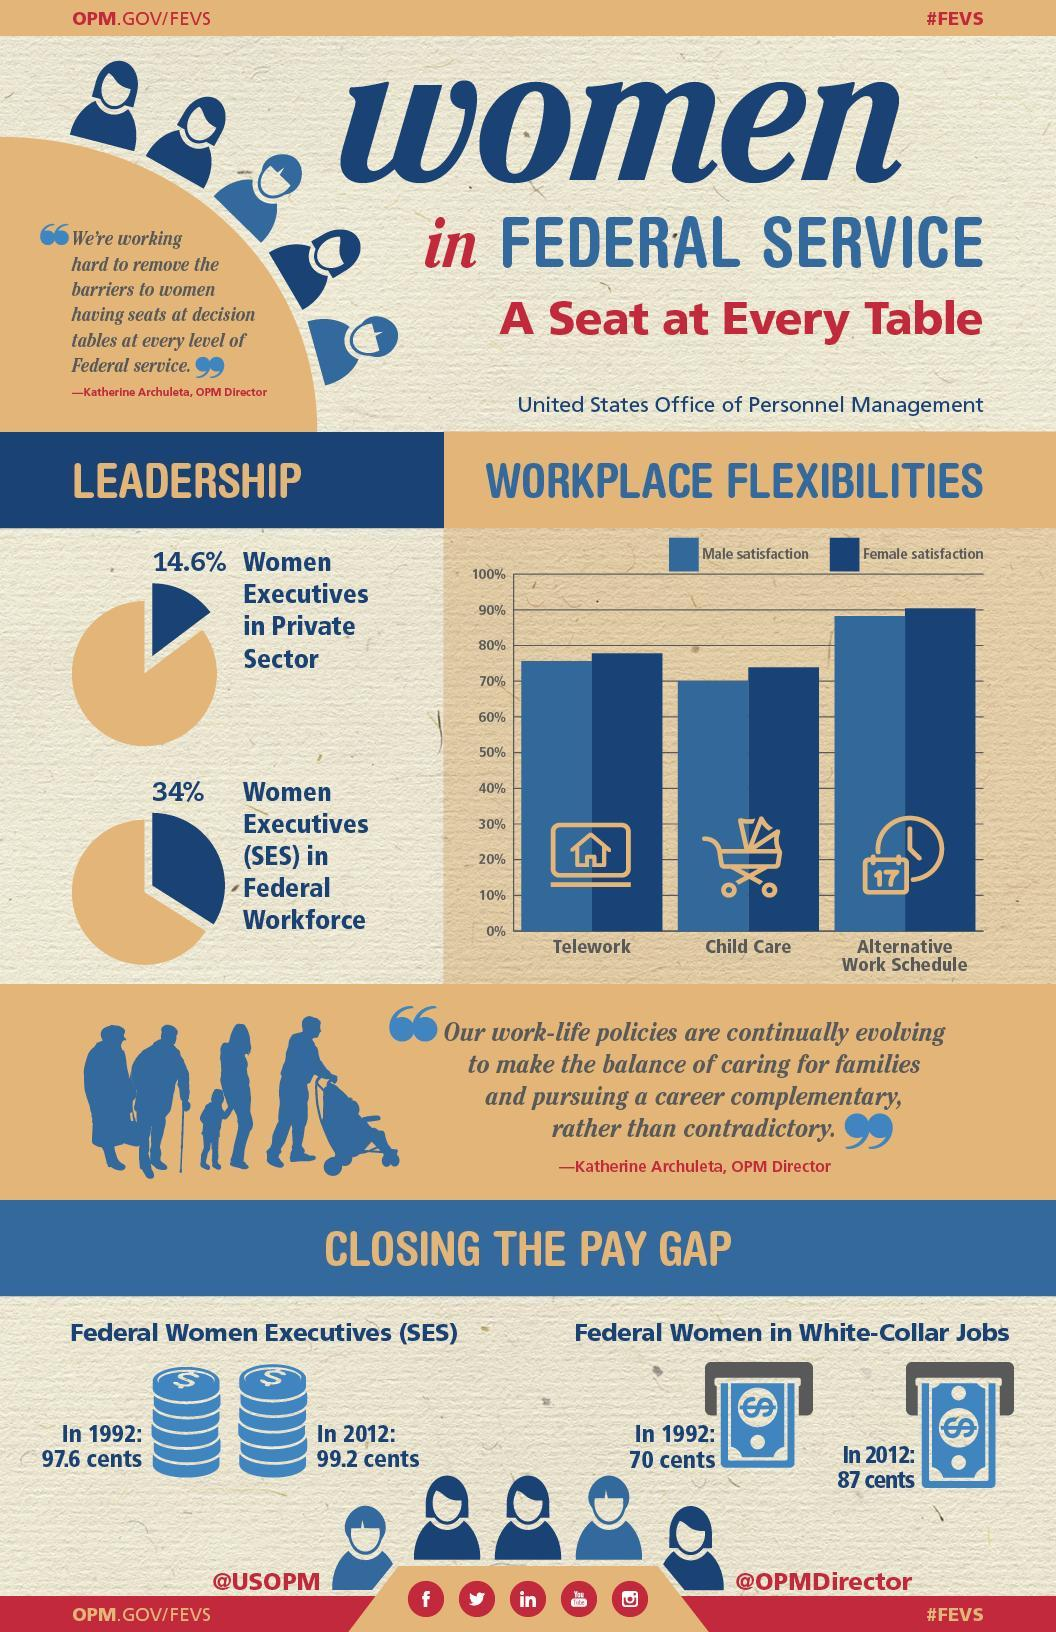What is the salary of federal women executives (SES) in the U.S. in 1992?
Answer the question with a short phrase. 97.6 cents What percent of all executive positions in the private sector of the U.S. are occupied by women? 14.6% What is the salary of federal women employees in white-collar jobs in the U.S. in 2012? 87 cents What percent of all SES positions in the federal workforce of the U.S. are occupied by women? 34% What is the female satisfaction rate in the U.S. for an alternative work schedule? 90% 